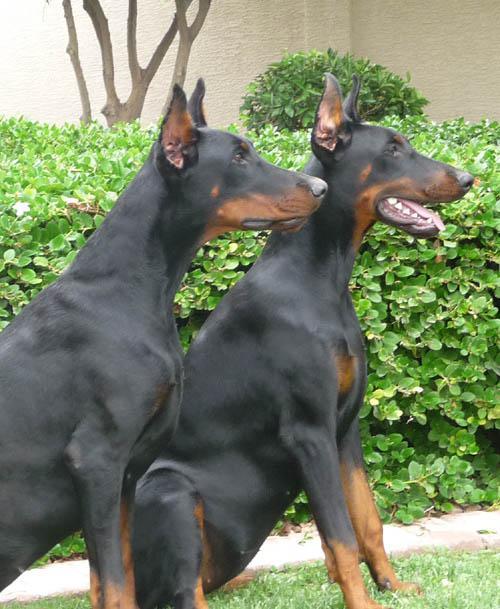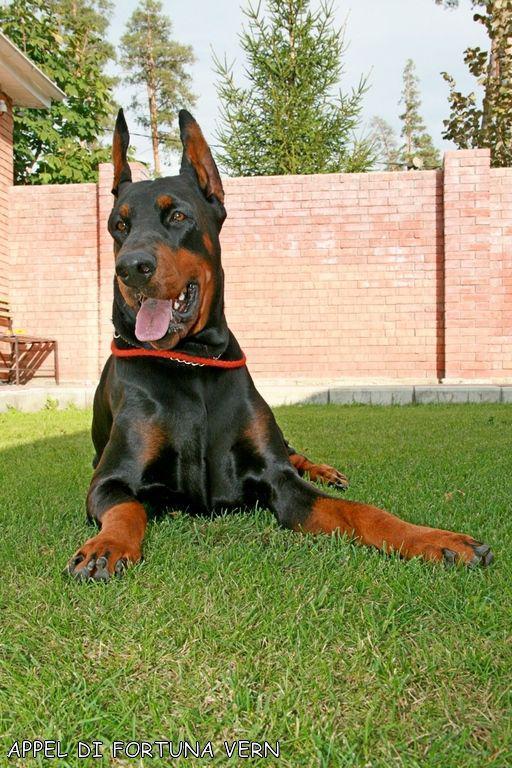The first image is the image on the left, the second image is the image on the right. Analyze the images presented: Is the assertion "There are three dogs sitting or laying on the grass." valid? Answer yes or no. Yes. The first image is the image on the left, the second image is the image on the right. For the images displayed, is the sentence "The right image contains a reclining doberman with erect ears." factually correct? Answer yes or no. Yes. 